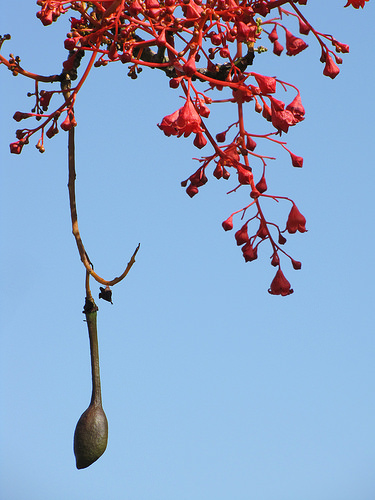<image>
Is there a flower in the sky? No. The flower is not contained within the sky. These objects have a different spatial relationship. 